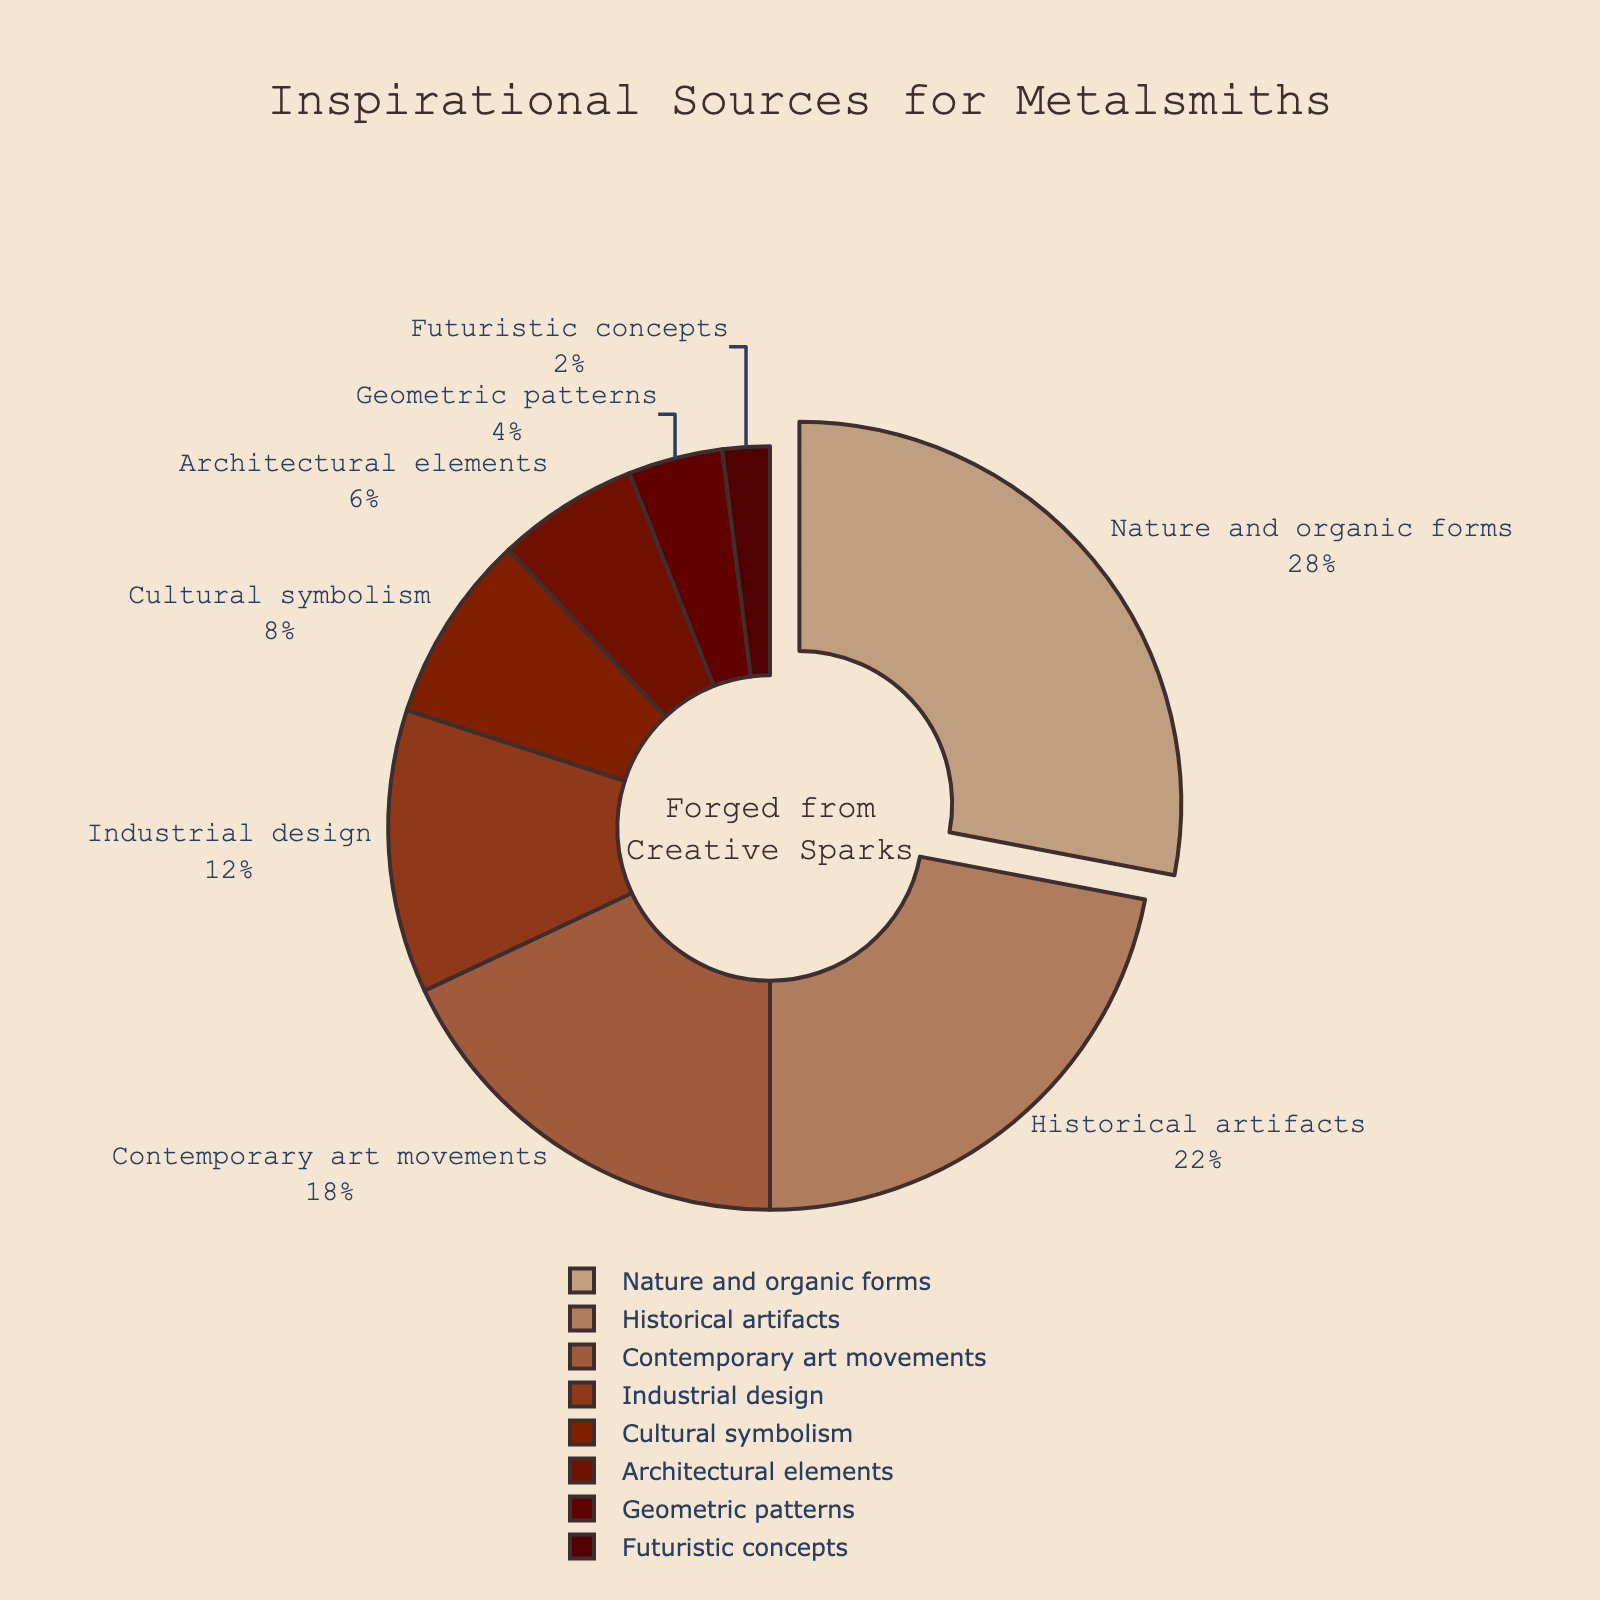What is the most common inspirational source for metalsmiths? The largest section of the pie chart represents the most common source. "Nature and organic forms" takes up the largest portion at 28%.
Answer: Nature and organic forms How do historical artifacts compare to contemporary art movements in terms of percentage? Historical artifacts take up 22% of the chart, while contemporary art movements take up 18%. 22% is larger than 18%.
Answer: Historical artifacts have a higher percentage than contemporary art movements What's the combined percentage of cultural symbolism and architectural elements? Cultural symbolism is 8% and architectural elements are 6%. Adding them yields 8% + 6% = 14%.
Answer: 14% Which source is cited least often by metalsmiths? The smallest section of the pie chart represents the least cited source. Futuristic concepts take up 2%, which is the smallest portion.
Answer: Futuristic concepts What is the total percentage represented by geometric patterns and futuristic concepts together? Geometric patterns have 4%, and futuristic concepts have 2%. Adding them together gives 4% + 2% = 6%.
Answer: 6% Is the percentage of industrial design greater than or less than historical artifacts? Industrial design is 12%, while historical artifacts are 22%. 12% is less than 22%.
Answer: Less What percentage difference is there between the most common and least common inspirational sources? The most common source is "Nature and organic forms" at 28%, and the least common is "Futuristic concepts" at 2%. Subtracting 2% from 28% gives 28% - 2% = 26%.
Answer: 26% How much larger is the percentage for nature and organic forms compared to industrial design? Nature and organic forms is 28%, and industrial design is 12%. Subtracting 12% from 28% gives 28% - 12% = 16%.
Answer: 16% What is the average percentage of historical artifacts, contemporary art movements, and industrial design combined? Sum the percentages: 22% + 18% + 12% = 52%. There are 3 sources, so dividing the sum by 3 gives 52% / 3 ≈ 17.33%.
Answer: 17.33% Is cultural symbolism cited more or less often than geometric patterns? Cultural symbolism is 8%, while geometric patterns are 4%. 8% is greater than 4%.
Answer: More 